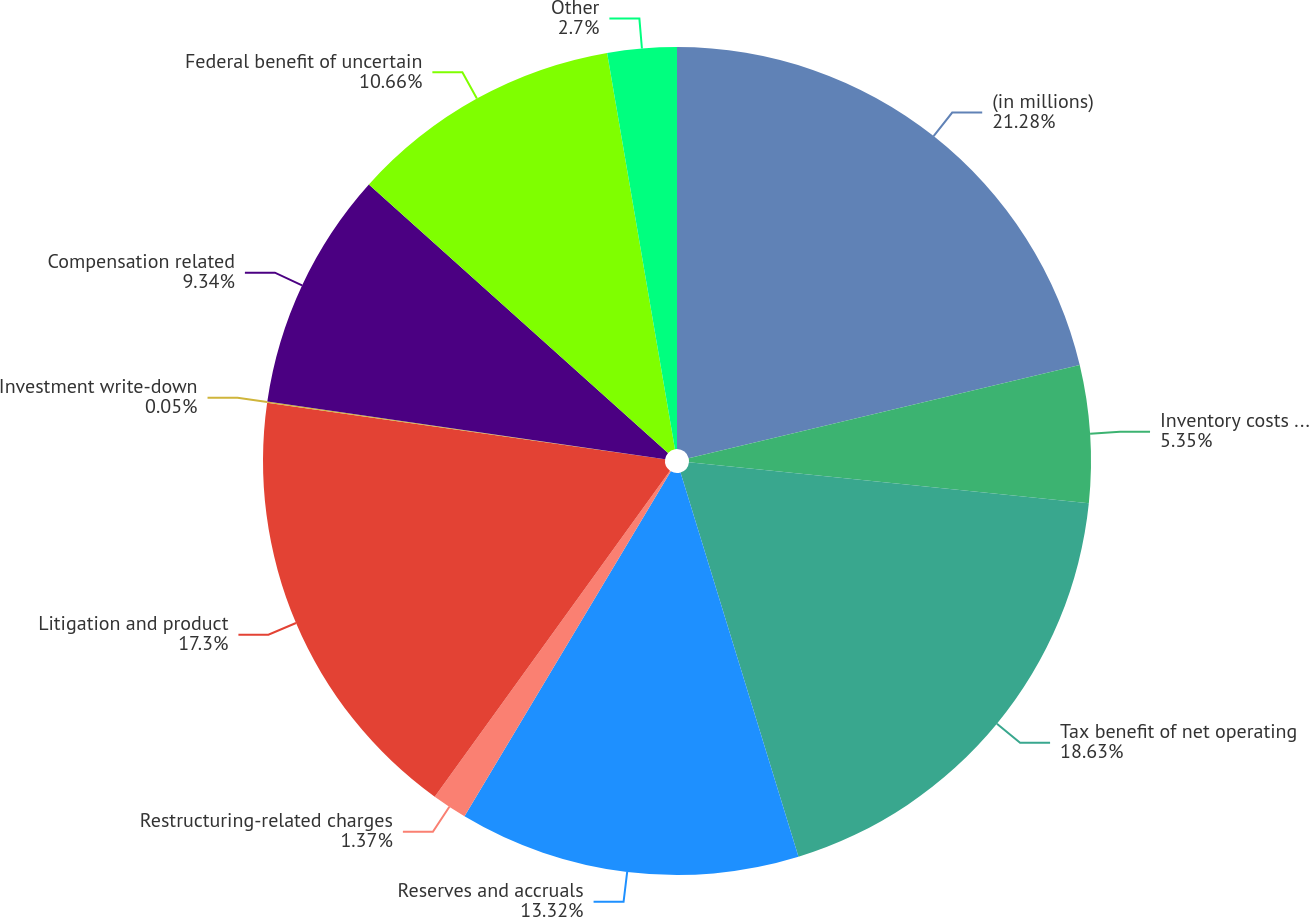Convert chart. <chart><loc_0><loc_0><loc_500><loc_500><pie_chart><fcel>(in millions)<fcel>Inventory costs and related<fcel>Tax benefit of net operating<fcel>Reserves and accruals<fcel>Restructuring-related charges<fcel>Litigation and product<fcel>Investment write-down<fcel>Compensation related<fcel>Federal benefit of uncertain<fcel>Other<nl><fcel>21.28%<fcel>5.35%<fcel>18.63%<fcel>13.32%<fcel>1.37%<fcel>17.3%<fcel>0.05%<fcel>9.34%<fcel>10.66%<fcel>2.7%<nl></chart> 